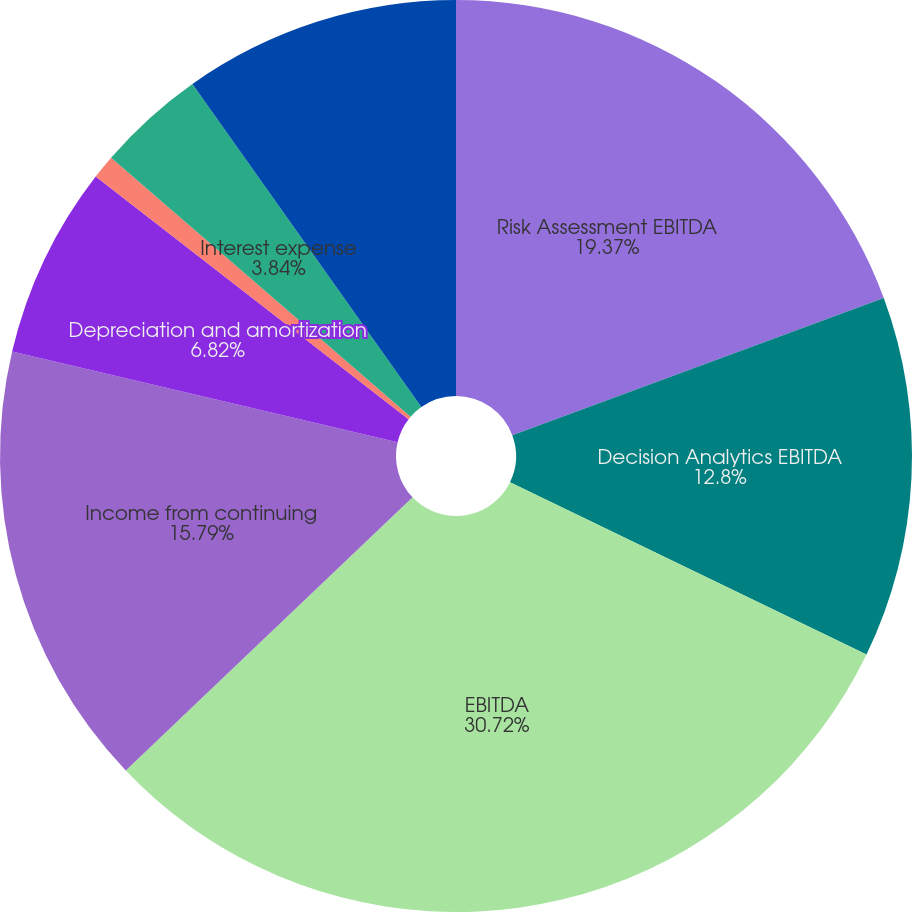Convert chart. <chart><loc_0><loc_0><loc_500><loc_500><pie_chart><fcel>Risk Assessment EBITDA<fcel>Decision Analytics EBITDA<fcel>EBITDA<fcel>Income from continuing<fcel>Depreciation and amortization<fcel>Investment income and realized<fcel>Interest expense<fcel>Provision for income taxes<nl><fcel>19.37%<fcel>12.8%<fcel>30.72%<fcel>15.79%<fcel>6.82%<fcel>0.85%<fcel>3.84%<fcel>9.81%<nl></chart> 